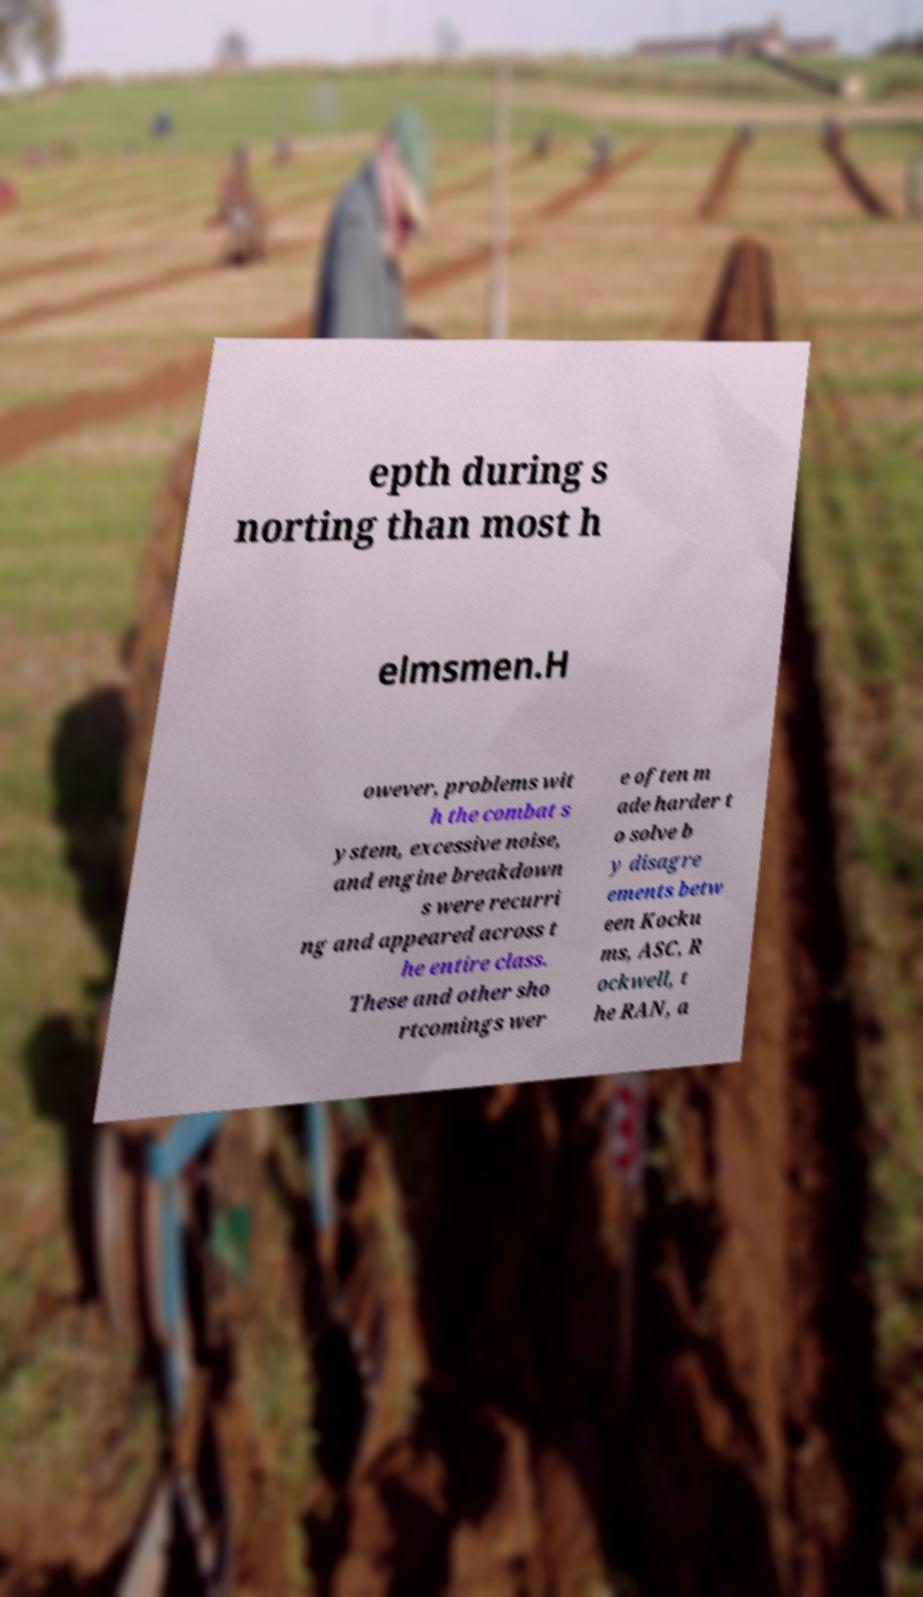Could you assist in decoding the text presented in this image and type it out clearly? epth during s norting than most h elmsmen.H owever, problems wit h the combat s ystem, excessive noise, and engine breakdown s were recurri ng and appeared across t he entire class. These and other sho rtcomings wer e often m ade harder t o solve b y disagre ements betw een Kocku ms, ASC, R ockwell, t he RAN, a 